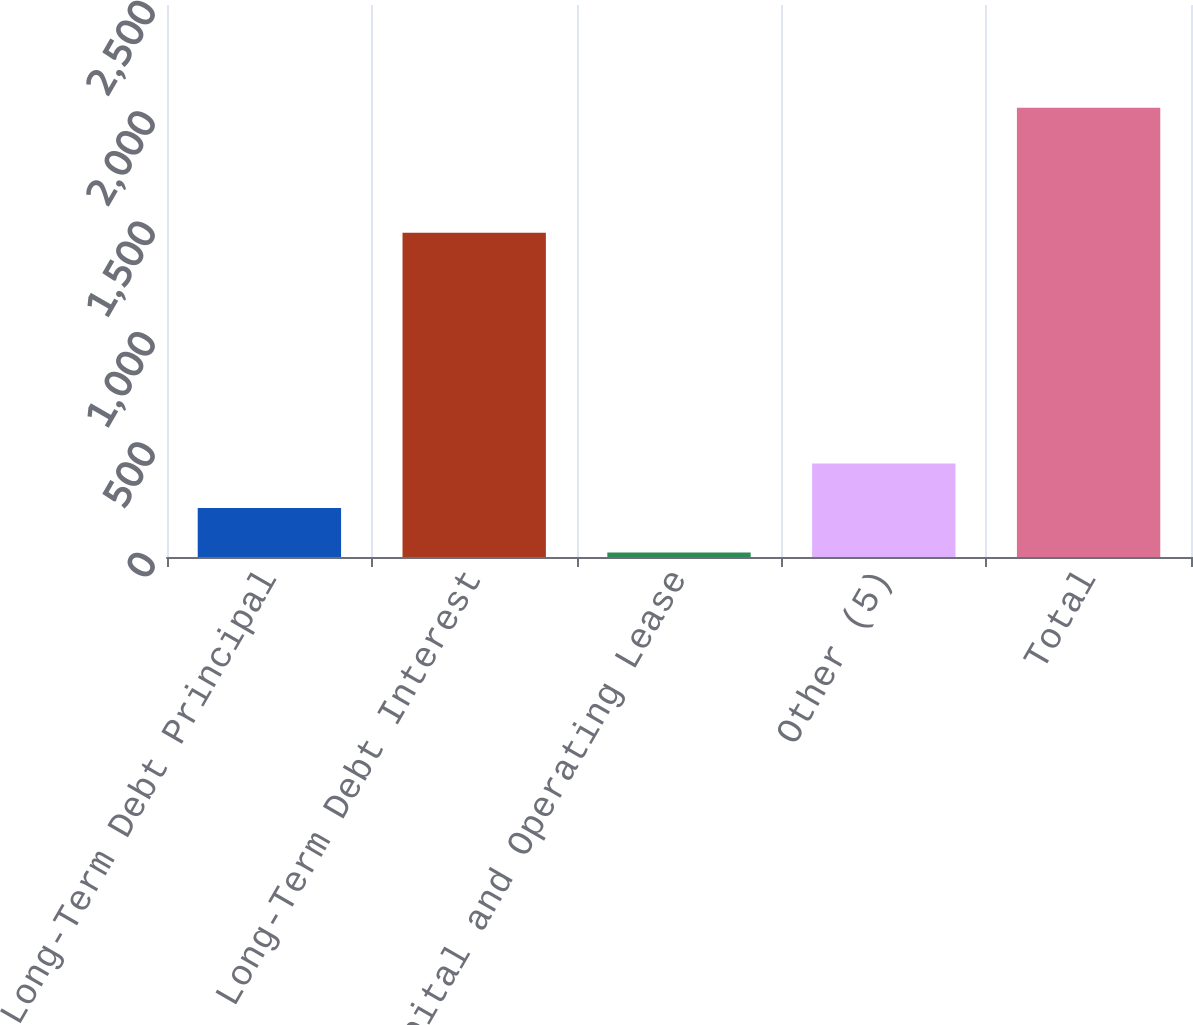Convert chart to OTSL. <chart><loc_0><loc_0><loc_500><loc_500><bar_chart><fcel>Long-Term Debt Principal<fcel>Long-Term Debt Interest<fcel>Capital and Operating Lease<fcel>Other (5)<fcel>Total<nl><fcel>221.5<fcel>1469<fcel>20<fcel>423<fcel>2035<nl></chart> 